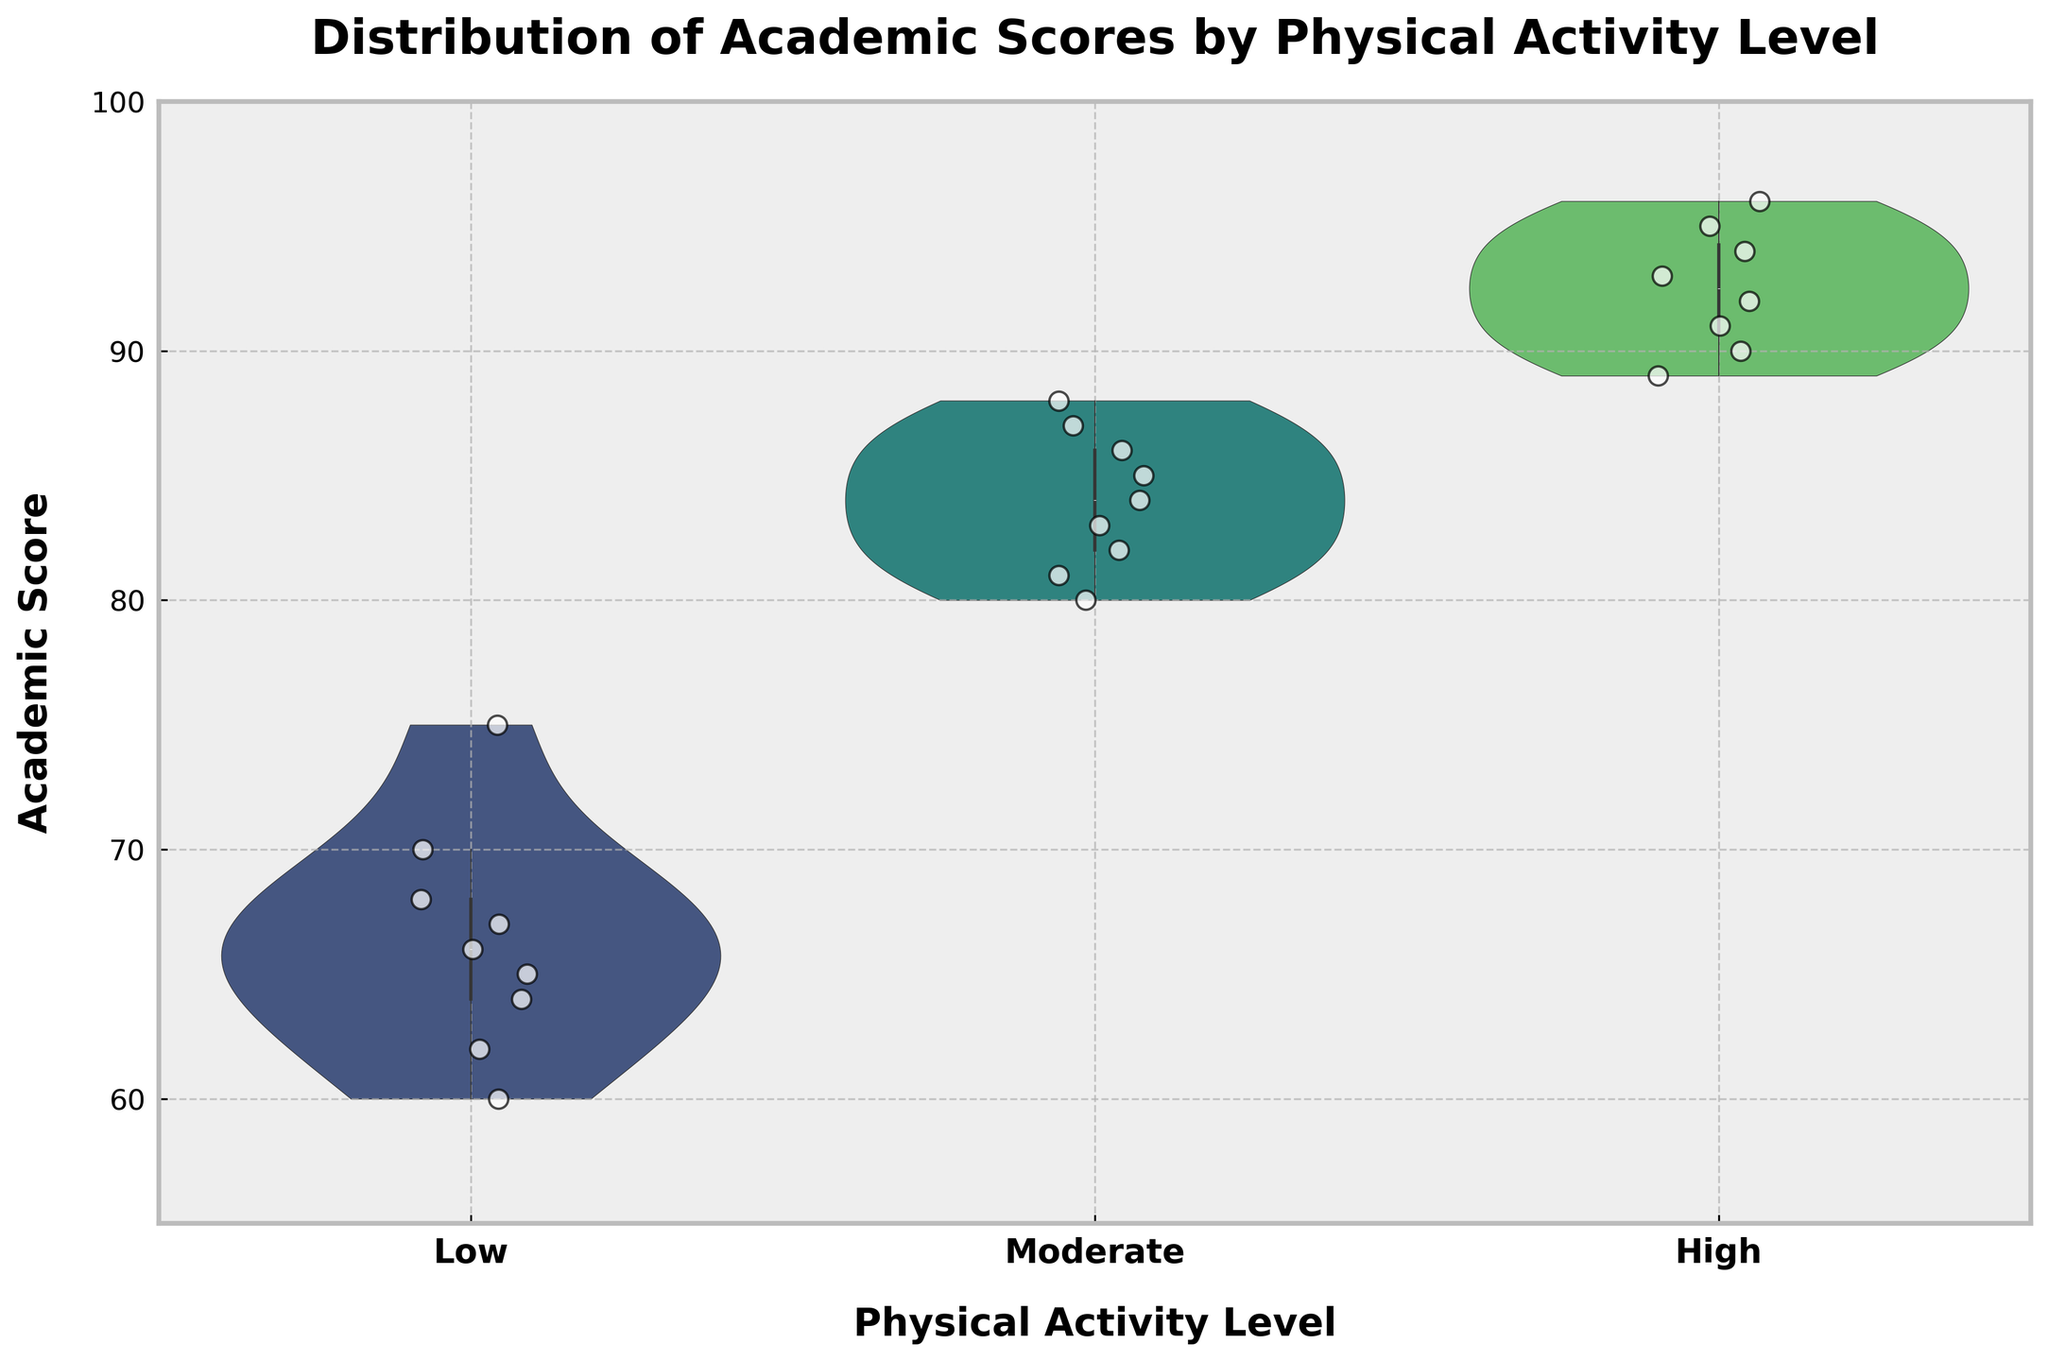What's the title of the figure? The title of the figure is displayed at the top, often in bold font to make it noticeable. Here, we see the title "Distribution of Academic Scores by Physical Activity Level."
Answer: Distribution of Academic Scores by Physical Activity Level What are the labels of the x-axis and y-axis? The labels are typically provided below the x-axis and beside the y-axis. In this figure, the x-axis label is "Physical Activity Level," and the y-axis label is "Academic Score."
Answer: Physical Activity Level, Academic Score How many categories of physical activity levels are shown in the x-axis? The x-axis categorizes data into distinct levels which are visually spaced apart. Here, there are three categories: "Low," "Moderate," and "High."
Answer: Three Which physical activity level group has the highest median academic score? The median is typically indicated by the thickest part of the violin plot or a central line for the distribution. The "High" group has the highest median as it's positioned highest on the y-axis.
Answer: High What is the range of academic scores for the 'Low' physical activity level category? The range is the difference between the highest and lowest points within the category on the y-axis. For the "Low" group, academic scores range between 60 and 75.
Answer: 60 to 75 Compare the dispersion of academic scores among the three physical activity levels. Which category has the widest range? The dispersion can be seen from the spread of the violin plot. The "Moderate" and "High" categories have a wider range compared to "Low," with "High" showing the widest spread.
Answer: High Which physical activity level shows the greatest number of individual data points (jittered points)? The jittered points, represented as small dots, give an indication of the frequency of data points. By counting, we see that both "Moderate" and "High" categories show more individual points compared to "Low."
Answer: Moderate and High What is the highest academic score recorded in the figure and under which physical activity level? The highest point on the y-axis represents the maximum academic score. This is at 96 in the "High" category.
Answer: 96, High How does the interquartile range (IQR) of the 'Moderate' activity level compare to that of the 'Low' level? IQR is visually shown by the filled part of the violin plot. The "Moderate" level shows a broader IQR compared to the "Low" level, indicating more variability in academic scores.
Answer: Broader What trend can be observed between physical activity level and academic score based on this figure? By observing the central tendencies and dispersions, we can see an upward trend where higher physical activity levels are associated with higher academic scores.
Answer: Higher activity levels are associated with higher academic scores 